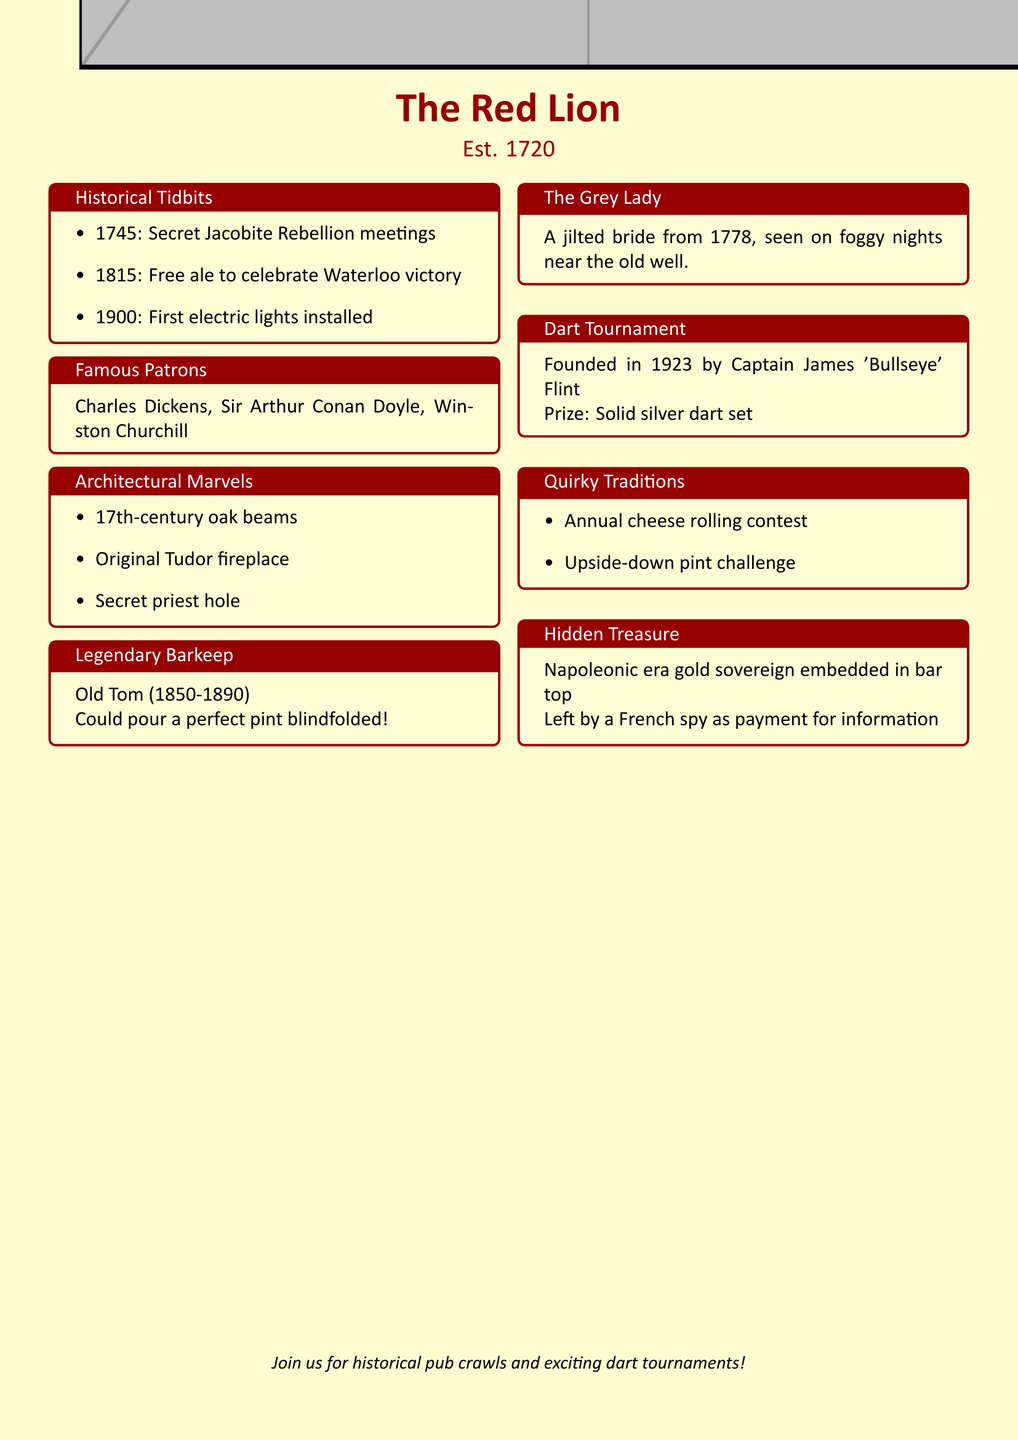What year was The Red Lion established? The establishment year of The Red Lion is explicitly mentioned in the document.
Answer: 1720 Who was the legendary barkeep during 1850-1890? The document identifies the legendary barkeep by name and the period he worked.
Answer: Old Tom What event was celebrated with free ale in 1815? The specific historical event is noted along with the year of celebration.
Answer: Wellington's victory at Waterloo What is embedded in the bar top as hidden treasure? The document states the hidden treasure and its type directly.
Answer: Napoleonic era gold sovereign In what year was the dart tournament founded? The founding year of the dart tournament is listed in the document.
Answer: 1923 Who held secret meetings at the pub in 1745? This historical detail is highlighted in the document under historical events.
Answer: Bonnie Prince Charlie's supporters What quirky tradition involves cheese? The document lists unique traditions, including one related to cheese.
Answer: Annual cheese rolling contest Who is known for pouring a perfect pint blindfolded? The document states the claim of the legendary barkeep, explicitly mentioning his ability.
Answer: Old Tom What is the appearance of the ghost known as The Grey Lady? The document provides a description of the ghost's appearance on certain nights.
Answer: Foggy nights near the old well 